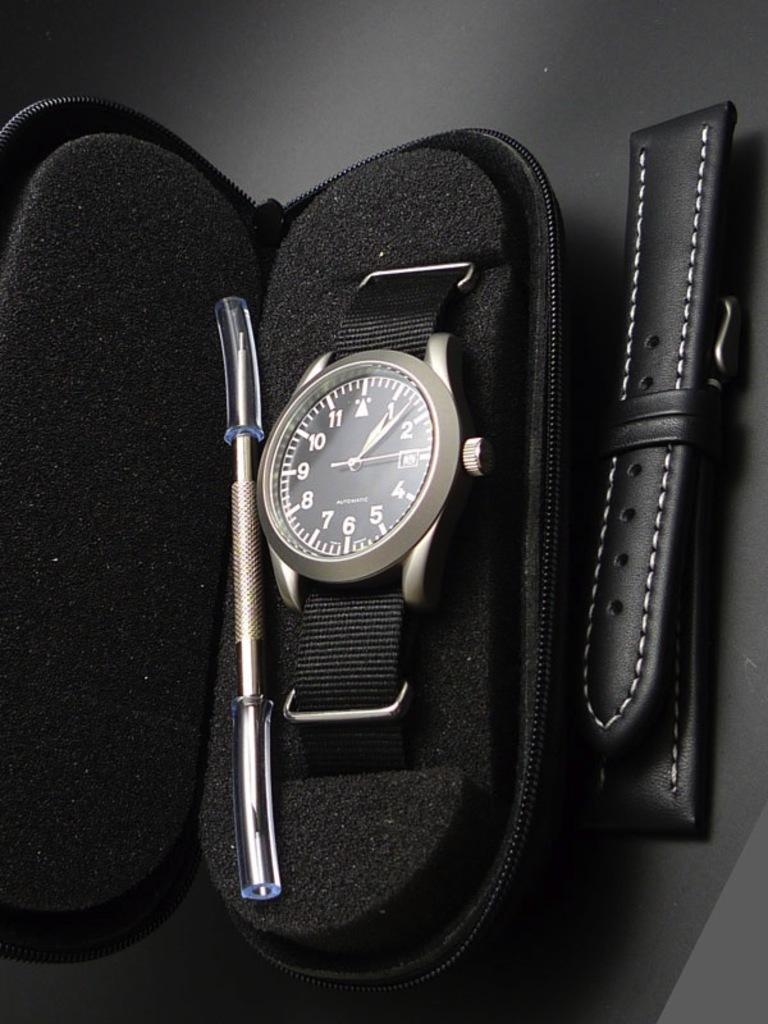<image>
Create a compact narrative representing the image presented. A watch showing the time as 1:08 is nestled in a case. 